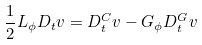<formula> <loc_0><loc_0><loc_500><loc_500>\frac { 1 } { 2 } L _ { \phi } D _ { t } v = D _ { t } ^ { C } v - G _ { \phi } D _ { t } ^ { G } v</formula> 